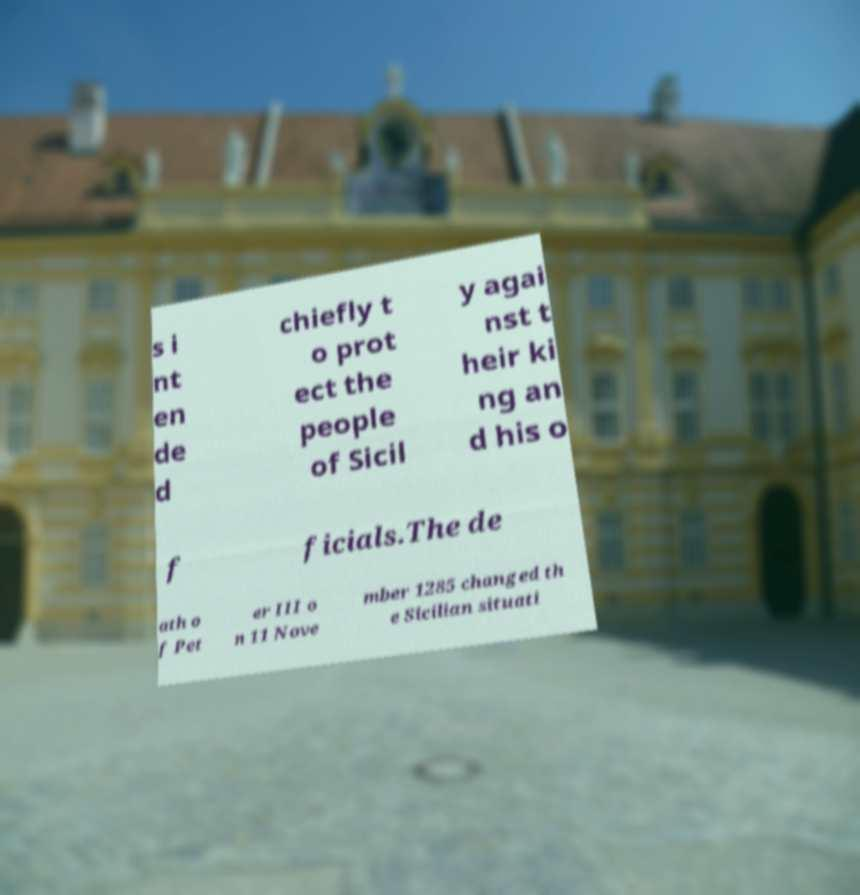For documentation purposes, I need the text within this image transcribed. Could you provide that? s i nt en de d chiefly t o prot ect the people of Sicil y agai nst t heir ki ng an d his o f ficials.The de ath o f Pet er III o n 11 Nove mber 1285 changed th e Sicilian situati 